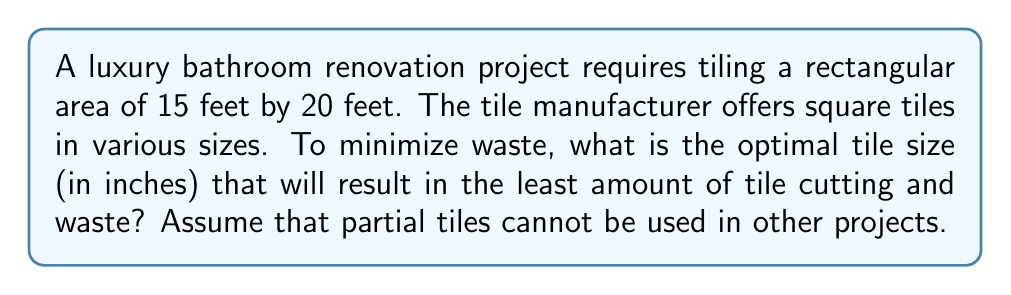Can you answer this question? Let's approach this step-by-step:

1) First, convert the room dimensions to inches:
   15 feet = 15 × 12 = 180 inches
   20 feet = 20 × 12 = 240 inches

2) The optimal tile size will be a factor of both dimensions. We need to find the Greatest Common Divisor (GCD) of 180 and 240.

3) To find the GCD, let's use the Euclidean algorithm:
   
   240 = 1 × 180 + 60
   180 = 3 × 60 + 0

   Therefore, the GCD of 180 and 240 is 60.

4) This means that any tile size that is a factor of 60 inches will fit perfectly without any cutting or waste.

5) The factors of 60 are: 1, 2, 3, 4, 5, 6, 10, 12, 15, 20, 30, 60

6) However, we need to consider practical tile sizes for a luxury bathroom. Tiles that are too small (like 1 or 2 inches) or too large (like 60 inches) would not be suitable.

7) Among the practical options, the largest size would be preferable as it would result in fewer grout lines and a more luxurious appearance.

8) The largest practical size from our list is 30 inches.

9) Let's verify:
   180 ÷ 30 = 6 tiles
   240 ÷ 30 = 8 tiles

   Total tiles needed: 6 × 8 = 48 tiles

   This fits perfectly without any cutting or waste.
Answer: 30 inches 